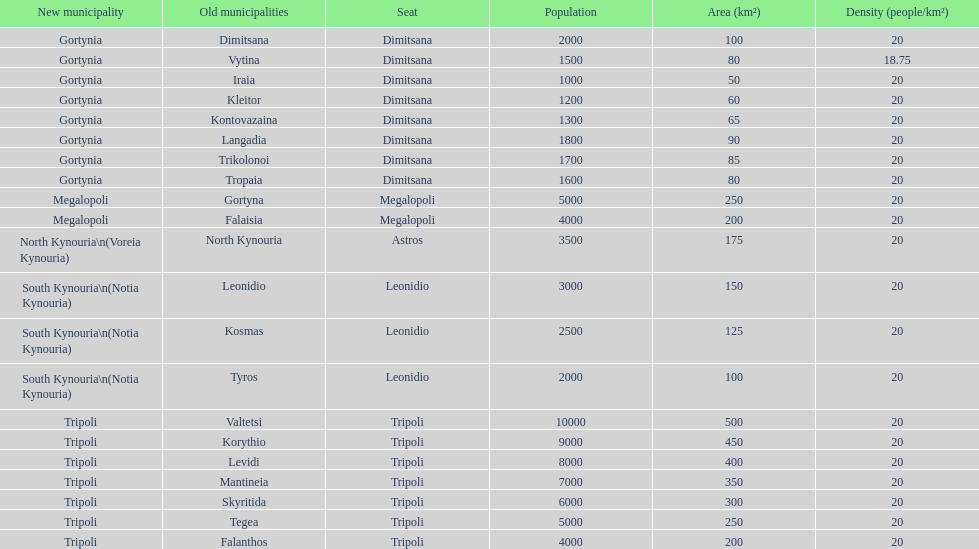What was the number of ancient municipalities in tripoli? 8. 